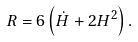Convert formula to latex. <formula><loc_0><loc_0><loc_500><loc_500>R = 6 \left ( \dot { H } + 2 H ^ { 2 } \right ) .</formula> 